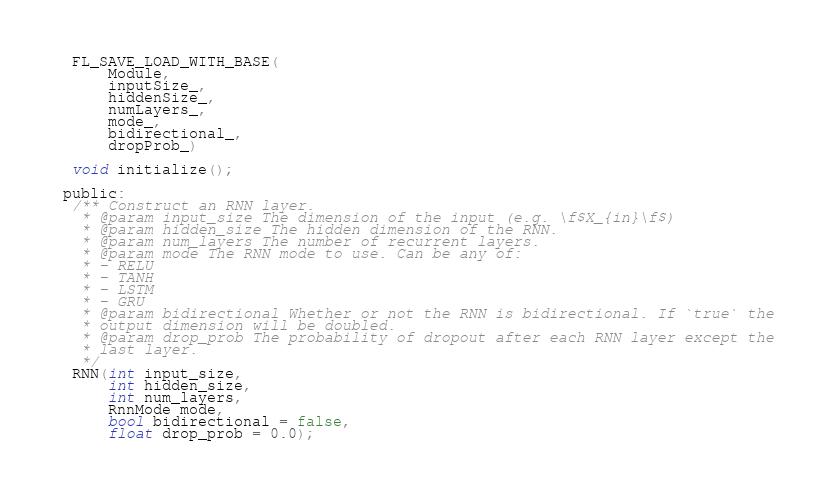Convert code to text. <code><loc_0><loc_0><loc_500><loc_500><_C_>
  FL_SAVE_LOAD_WITH_BASE(
      Module,
      inputSize_,
      hiddenSize_,
      numLayers_,
      mode_,
      bidirectional_,
      dropProb_)

  void initialize();

 public:
  /** Construct an RNN layer.
   * @param input_size The dimension of the input (e.g. \f$X_{in}\f$)
   * @param hidden_size The hidden dimension of the RNN.
   * @param num_layers The number of recurrent layers.
   * @param mode The RNN mode to use. Can be any of:
   * - RELU
   * - TANH
   * - LSTM
   * - GRU
   * @param bidirectional Whether or not the RNN is bidirectional. If `true` the
   * output dimension will be doubled.
   * @param drop_prob The probability of dropout after each RNN layer except the
   * last layer.
   */
  RNN(int input_size,
      int hidden_size,
      int num_layers,
      RnnMode mode,
      bool bidirectional = false,
      float drop_prob = 0.0);
</code> 